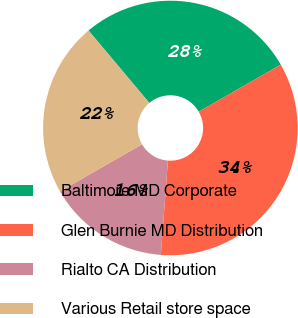<chart> <loc_0><loc_0><loc_500><loc_500><pie_chart><fcel>Baltimore MD Corporate<fcel>Glen Burnie MD Distribution<fcel>Rialto CA Distribution<fcel>Various Retail store space<nl><fcel>27.83%<fcel>34.48%<fcel>15.51%<fcel>22.18%<nl></chart> 